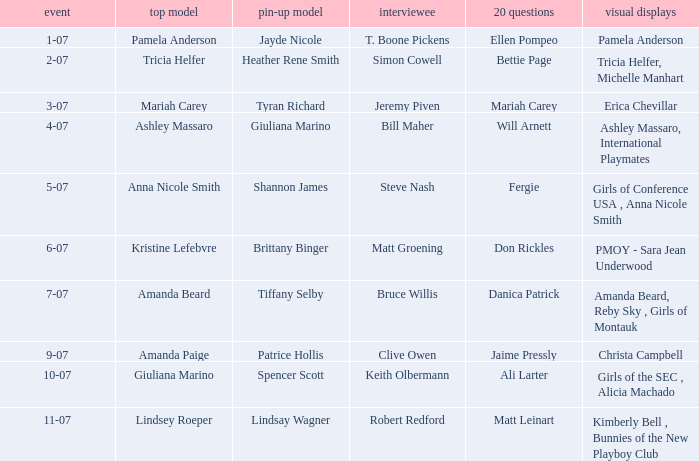Who was the cover model when the issue's pictorials was pmoy - sara jean underwood? Kristine Lefebvre. 